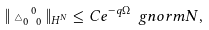<formula> <loc_0><loc_0><loc_500><loc_500>\| \triangle _ { 0 \ 0 } ^ { \ 0 } \| _ { H ^ { N } } \leq C e ^ { - q \Omega } \ g n o r m { N } ,</formula> 